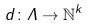Convert formula to latex. <formula><loc_0><loc_0><loc_500><loc_500>d \colon \Lambda \rightarrow \mathbb { N } ^ { k }</formula> 